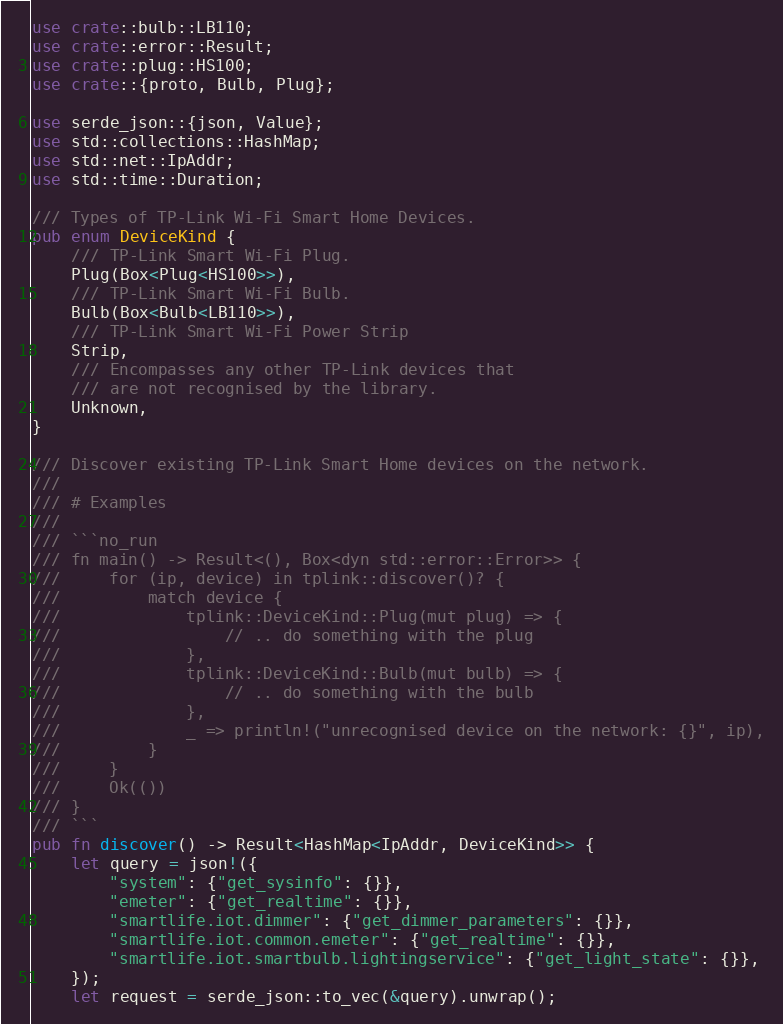Convert code to text. <code><loc_0><loc_0><loc_500><loc_500><_Rust_>use crate::bulb::LB110;
use crate::error::Result;
use crate::plug::HS100;
use crate::{proto, Bulb, Plug};

use serde_json::{json, Value};
use std::collections::HashMap;
use std::net::IpAddr;
use std::time::Duration;

/// Types of TP-Link Wi-Fi Smart Home Devices.
pub enum DeviceKind {
    /// TP-Link Smart Wi-Fi Plug.
    Plug(Box<Plug<HS100>>),
    /// TP-Link Smart Wi-Fi Bulb.
    Bulb(Box<Bulb<LB110>>),
    /// TP-Link Smart Wi-Fi Power Strip
    Strip,
    /// Encompasses any other TP-Link devices that
    /// are not recognised by the library.
    Unknown,
}

/// Discover existing TP-Link Smart Home devices on the network.
///
/// # Examples
///
/// ```no_run
/// fn main() -> Result<(), Box<dyn std::error::Error>> {
///     for (ip, device) in tplink::discover()? {
///         match device {
///             tplink::DeviceKind::Plug(mut plug) => {
///                 // .. do something with the plug
///             },
///             tplink::DeviceKind::Bulb(mut bulb) => {
///                 // .. do something with the bulb
///             },
///             _ => println!("unrecognised device on the network: {}", ip),
///         }
///     }
///     Ok(())
/// }
/// ```
pub fn discover() -> Result<HashMap<IpAddr, DeviceKind>> {
    let query = json!({
        "system": {"get_sysinfo": {}},
        "emeter": {"get_realtime": {}},
        "smartlife.iot.dimmer": {"get_dimmer_parameters": {}},
        "smartlife.iot.common.emeter": {"get_realtime": {}},
        "smartlife.iot.smartbulb.lightingservice": {"get_light_state": {}},
    });
    let request = serde_json::to_vec(&query).unwrap();</code> 